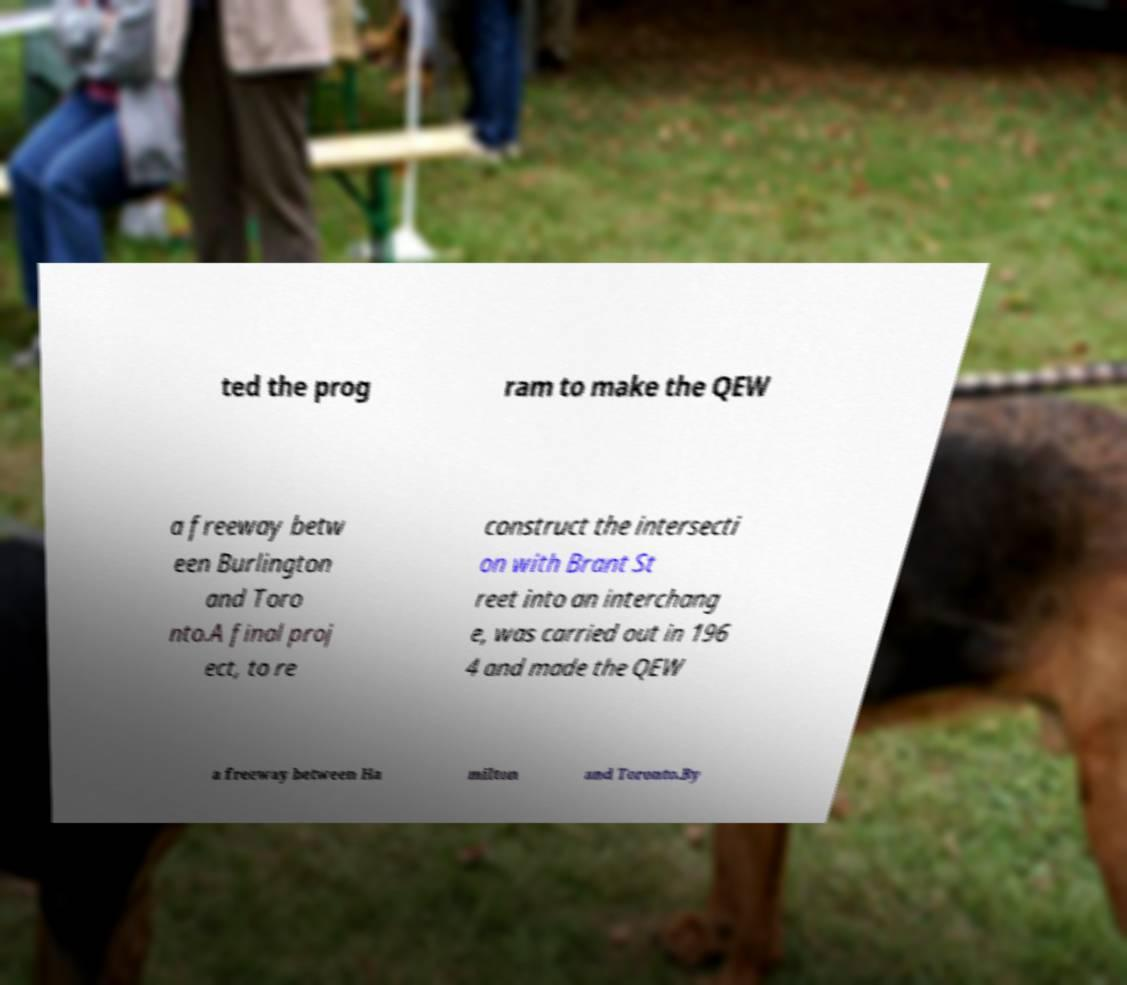There's text embedded in this image that I need extracted. Can you transcribe it verbatim? ted the prog ram to make the QEW a freeway betw een Burlington and Toro nto.A final proj ect, to re construct the intersecti on with Brant St reet into an interchang e, was carried out in 196 4 and made the QEW a freeway between Ha milton and Toronto.By 